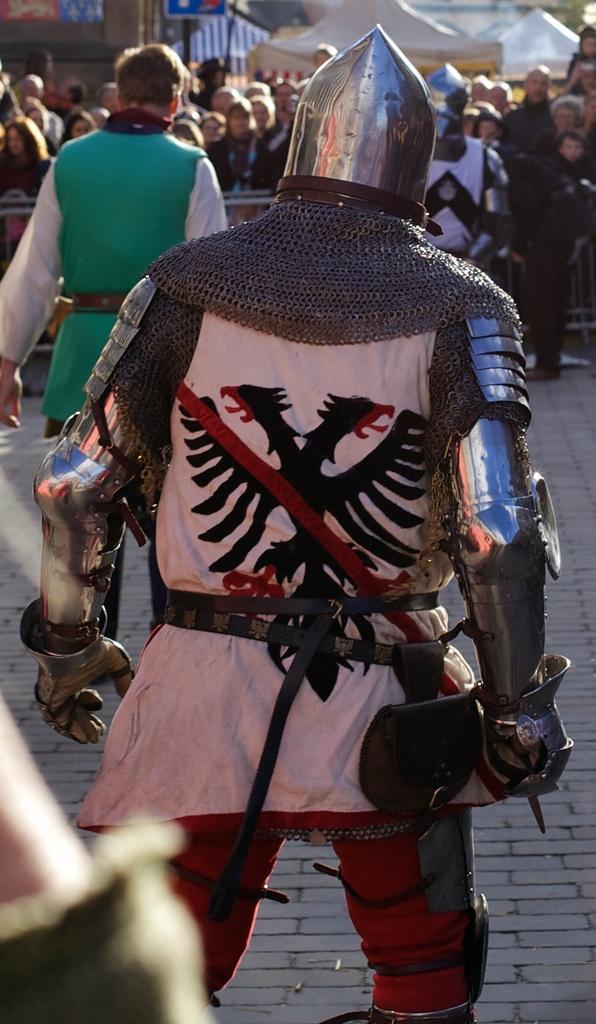How would you summarize this image in a sentence or two? In the center of the image we can see persons on the ground. In the background we can see persons, tents and building. 